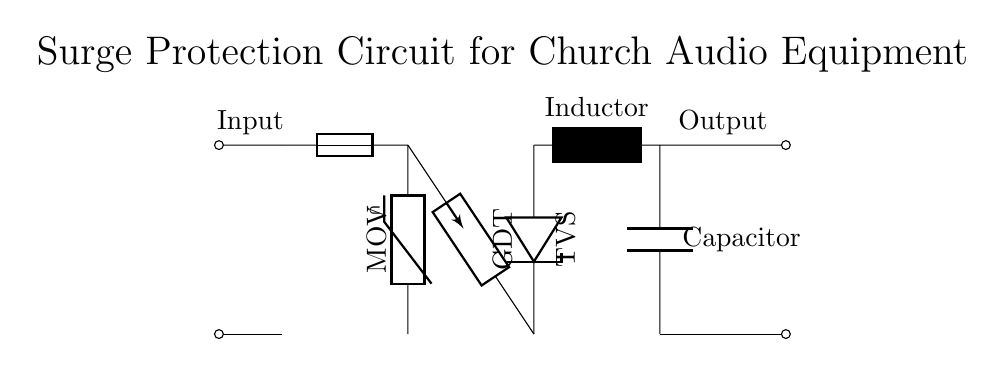What type of circuit is this? The circuit is a surge protection circuit designed to protect audio equipment from voltage spikes. The presence of protective components such as a MOV, GDT, and TVS indicates its purpose.
Answer: Surge protection What is the purpose of the MOV? The MOV, or Metal Oxide Varistor, is used to clamp voltage spikes and protect the circuit from overvoltage conditions. It operates by diverting excess voltage away from the connected components.
Answer: Overvoltage protection How many inductors are present in this circuit? There is one inductor shown in the circuit diagram, specifically located after the TVS diode and before the capacitor.
Answer: One What component follows the gas discharge tube? The component that follows the gas discharge tube in the circuit is the TVS diode, which provides additional protection by clamping voltage transients to a safe level for sensitive equipment.
Answer: TVS diode What is connected to ground in this circuit? The capacitor connected to the ground serves to filter remaining noise or voltage spikes and stabilize the circuit's performance.
Answer: Capacitor Explain the sequence of protection components in this circuit. The sequence starts with the MOV, which provides initial overvoltage protection, followed by the gas discharge tube, which handles large surges. Next is the TVS diode, which clamps residual voltage spikes. Lastly, the inductor and capacitor work together to filter the output to the audio equipment, smoothing the supply.
Answer: MOV, GDT, TVS, Inductor, Capacitor 